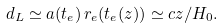Convert formula to latex. <formula><loc_0><loc_0><loc_500><loc_500>d _ { L } \simeq a ( t _ { e } ) \, r _ { e } ( t _ { e } ( z ) ) \simeq c z / H _ { 0 } .</formula> 